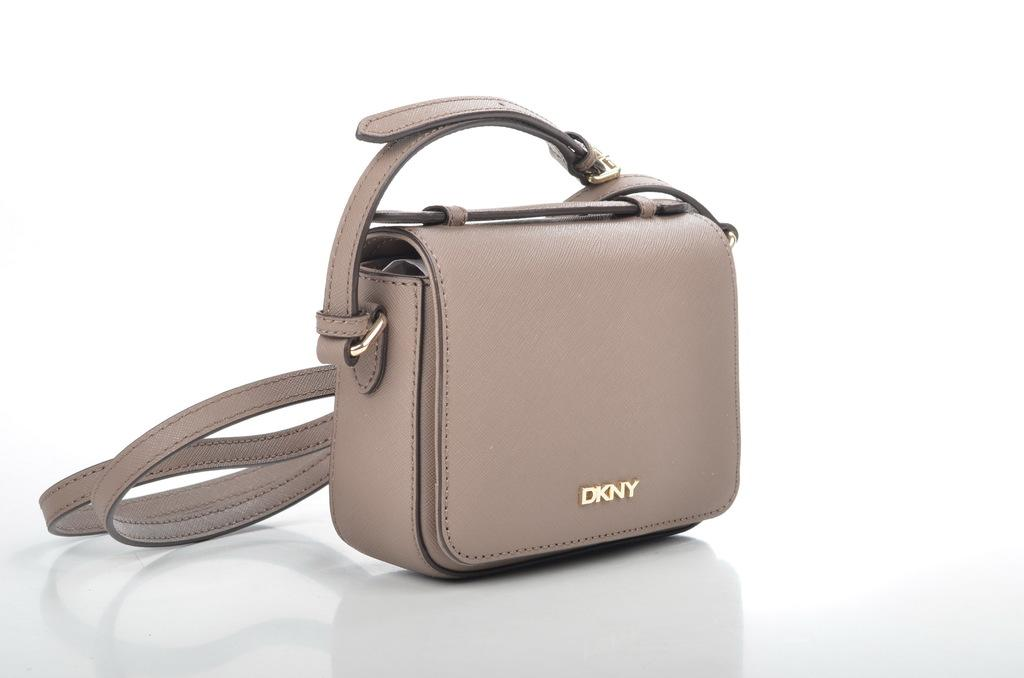What object can be seen in the image? There is a purse in the image. What color is the purse? The purse is in ash color. What part of the purse is also in ash color? The handle of the purse is also in ash color. How does the fog affect the ground in the image? There is no fog present in the image, as it only features a purse with an ash-colored handle. 